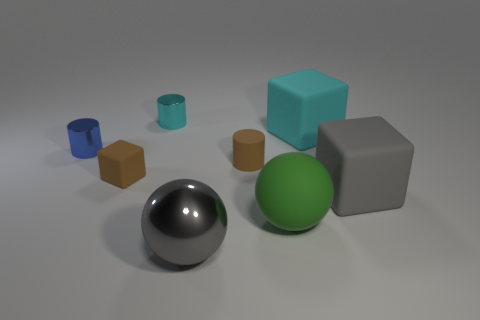What material is the large cube that is the same color as the large metal sphere?
Provide a short and direct response. Rubber. How big is the block that is both in front of the brown matte cylinder and left of the gray cube?
Your response must be concise. Small. What number of other objects are there of the same color as the rubber cylinder?
Your answer should be very brief. 1. What size is the thing behind the cyan thing right of the green rubber sphere that is to the right of the tiny cyan object?
Offer a very short reply. Small. Does the brown rubber cylinder have the same size as the sphere behind the metallic sphere?
Provide a short and direct response. No. Is the size of the gray object that is behind the gray sphere the same as the cylinder that is behind the tiny blue thing?
Your response must be concise. No. What is the color of the tiny rubber object that is right of the large gray object in front of the large gray thing that is to the right of the big green object?
Keep it short and to the point. Brown. Are there fewer large green rubber spheres that are right of the green matte sphere than cylinders in front of the tiny brown rubber block?
Keep it short and to the point. No. Do the cyan shiny thing and the gray matte thing have the same shape?
Your answer should be very brief. No. How many green balls are the same size as the gray metallic sphere?
Your response must be concise. 1. 